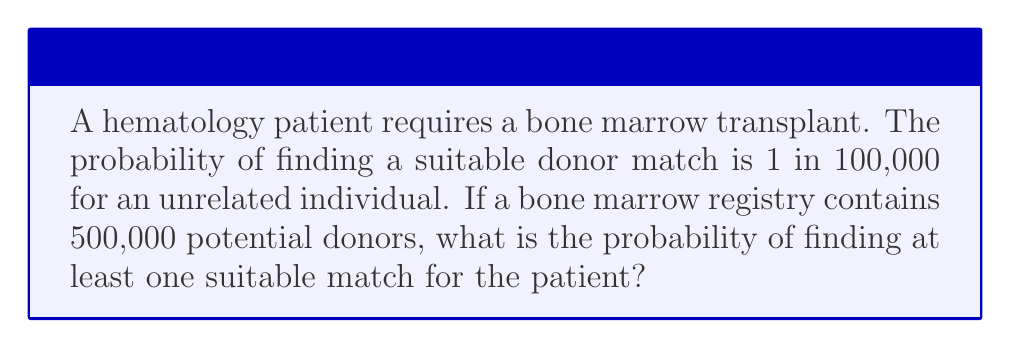Can you solve this math problem? Let's approach this step-by-step:

1) The probability of finding a match with one donor is $p = \frac{1}{100,000} = 0.00001$

2) The probability of not finding a match with one donor is $1 - p = 0.99999$

3) For 500,000 independent trials (donors), the probability of not finding a match with any donor is:

   $$(0.99999)^{500,000}$$

4) Therefore, the probability of finding at least one match is:

   $$1 - (0.99999)^{500,000}$$

5) Let's calculate this:
   
   $$1 - (0.99999)^{500,000} \approx 1 - e^{500,000 \ln(0.99999)}$$
   $$\approx 1 - e^{-5} \approx 0.9933$$

6) Convert to a percentage:

   $$0.9933 \times 100\% \approx 99.33\%$$
Answer: 99.33% 